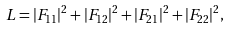<formula> <loc_0><loc_0><loc_500><loc_500>L = | F _ { 1 1 } | ^ { 2 } + | F _ { 1 2 } | ^ { 2 } + | F _ { 2 1 } | ^ { 2 } + | F _ { 2 2 } | ^ { 2 } ,</formula> 